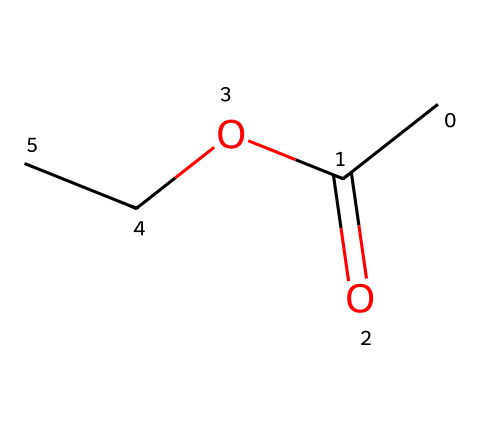How many carbon atoms are in ethyl acetate? The SMILES representation "CC(=O)OCC" indicates that there are two carbon atoms in the ethyl group (CC) and one carbon atom in the carbonyl group (C=O), making a total of three carbon atoms.
Answer: three What is the functional group present in ethyl acetate? The SMILES shows the presence of an ester group (characterized by the "C(=O)O" part, where a carbon atom is double-bonded to an oxygen atom and single-bonded to another oxygen atom). Therefore, the functional group is an ester.
Answer: ester How many oxygen atoms are present in ethyl acetate? In the SMILES "CC(=O)OCC", there are two oxygen atoms: one in the carbonyl group and one in the ester part (OCC). Therefore, the total number of oxygen atoms is two.
Answer: two What type of bonding is present between the carbon and oxygen in the carbonyl group? The carbon and oxygen in the carbonyl group (C=O) are connected by a double bond, which is indicative of strong bonding and the typical structure of a carbonyl in esters.
Answer: double bond Why is ethyl acetate classified as a solvent? Ethyl acetate has low viscosity and high volatility, making it effective at dissolving a variety of substances. Its ability to dissolve both polar and non-polar compounds qualifies it as a commonly used solvent in many industrial applications, including cleaning products.
Answer: solvent What is the ratio of carbon to oxygen atoms in ethyl acetate? The chemical structure of ethyl acetate shows three carbon atoms (C) and two oxygen atoms (O). To find the ratio, simply divide the number of carbon atoms by the number of oxygen atoms, yielding a ratio of 3:2.
Answer: 3:2 